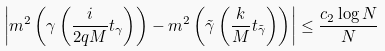Convert formula to latex. <formula><loc_0><loc_0><loc_500><loc_500>\left | m ^ { 2 } \left ( \gamma \left ( \frac { i } { 2 q M } t _ { \gamma } \right ) \right ) - m ^ { 2 } \left ( \tilde { \gamma } \left ( \frac { k } { M } t _ { \tilde { \gamma } } \right ) \right ) \right | \leq \frac { c _ { 2 } \log N } { N }</formula> 